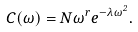Convert formula to latex. <formula><loc_0><loc_0><loc_500><loc_500>C ( \omega ) = N \omega ^ { r } e ^ { - \lambda \omega ^ { 2 } } .</formula> 